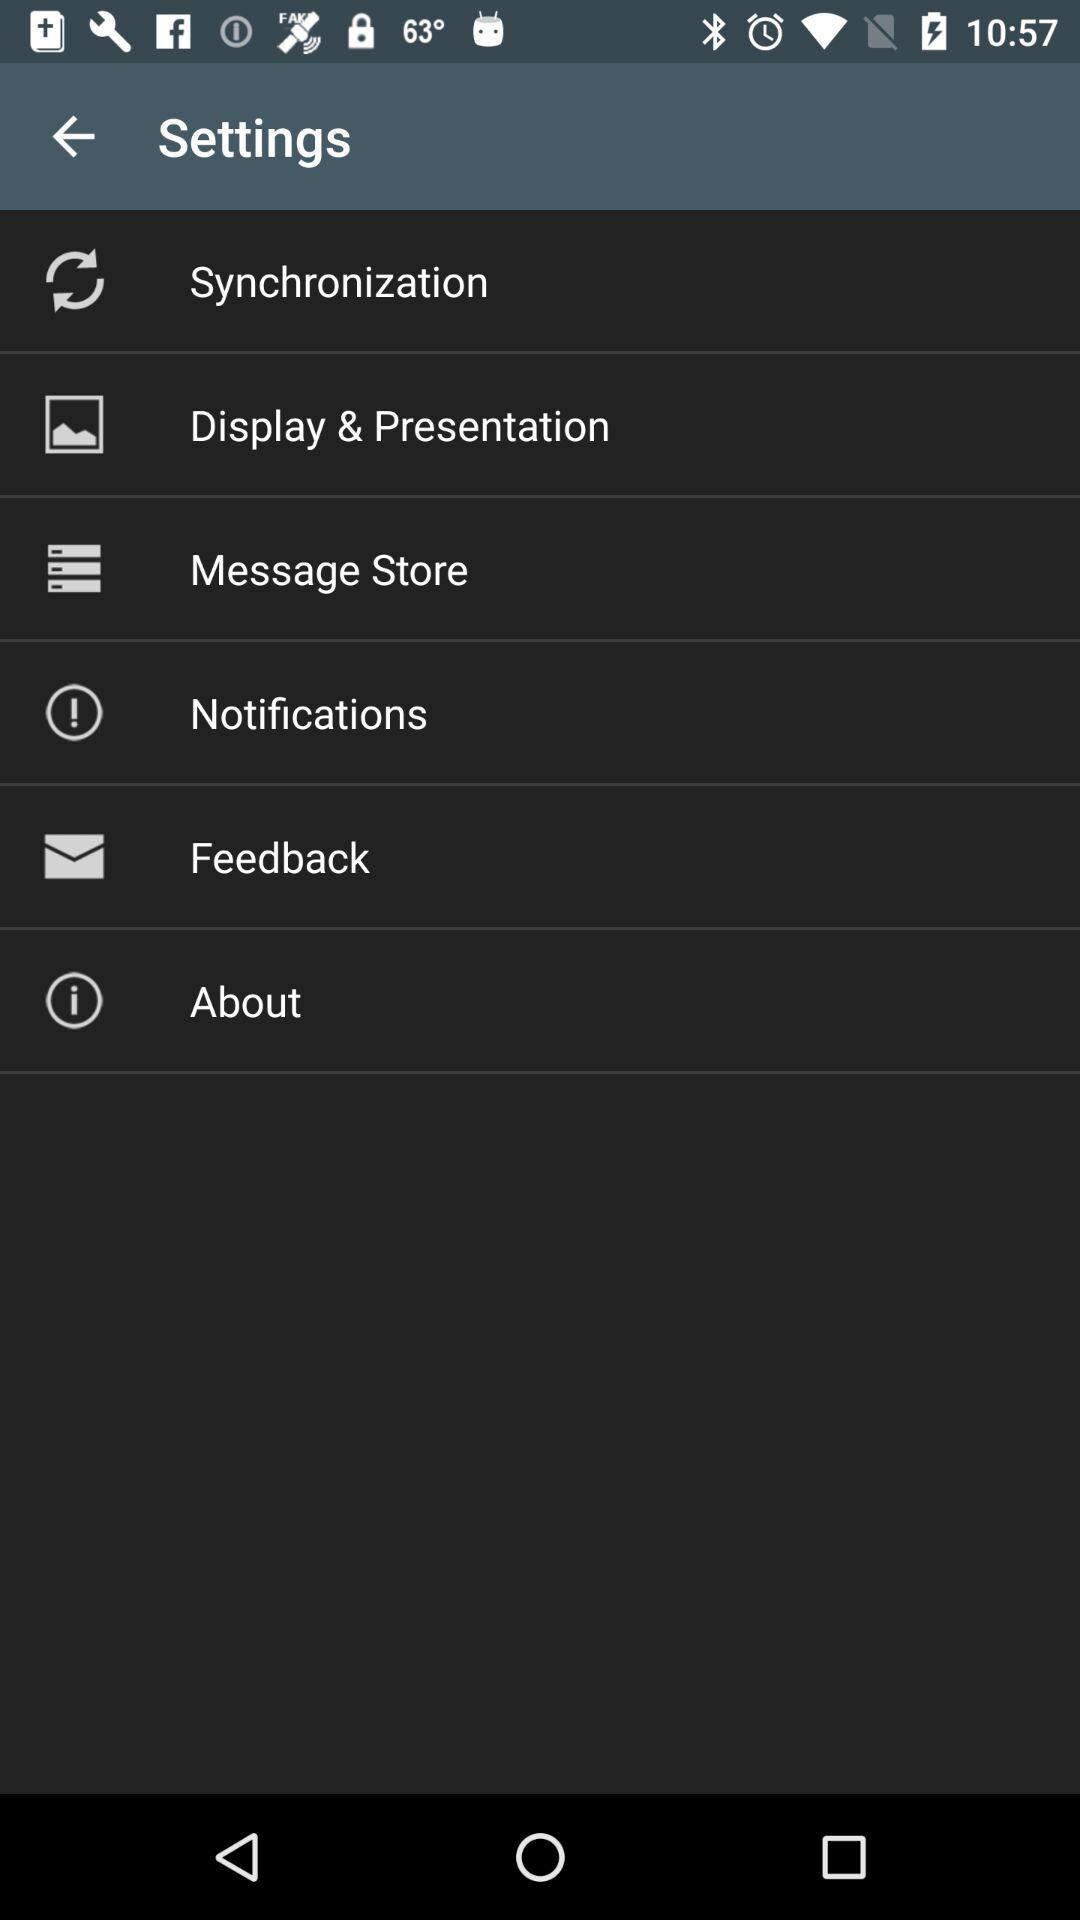How many items are in the settings menu?
Answer the question using a single word or phrase. 6 